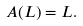<formula> <loc_0><loc_0><loc_500><loc_500>A ( L ) = L .</formula> 